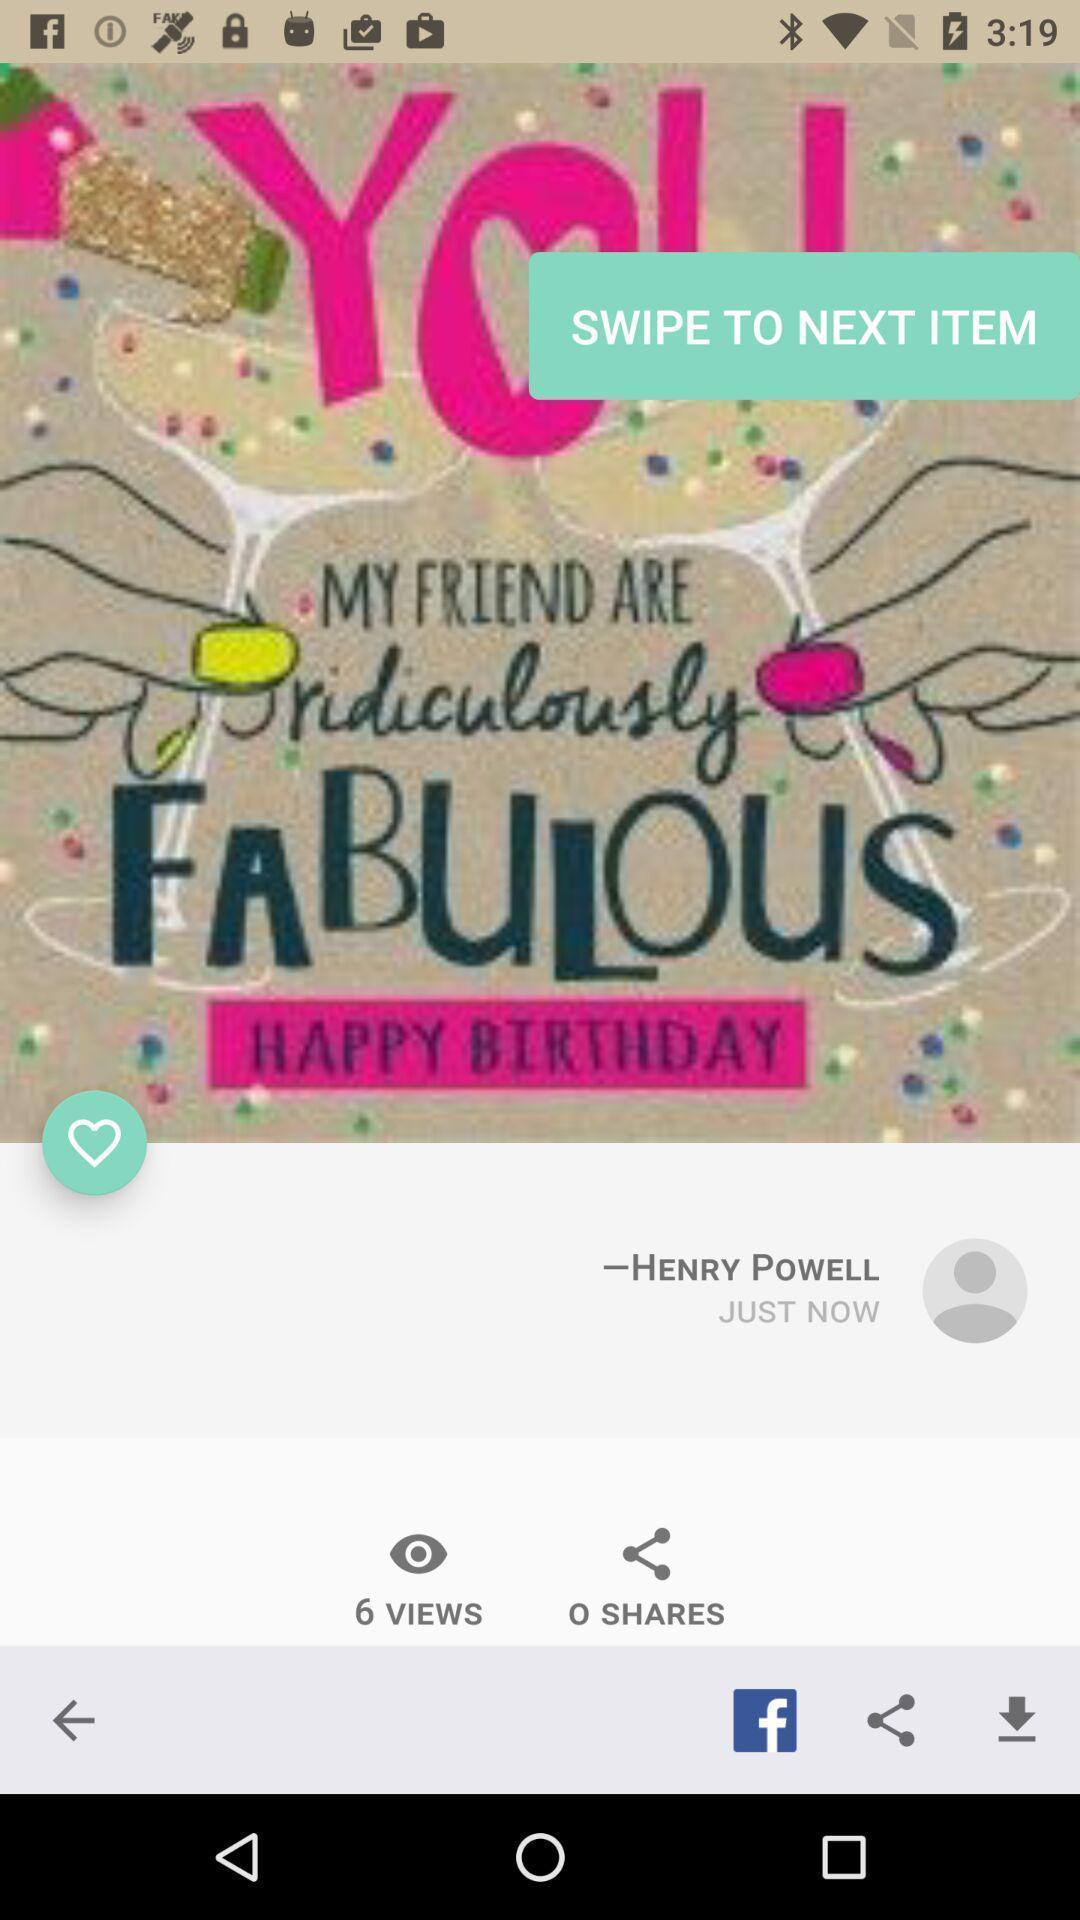Summarize the information in this screenshot. Screen shows a profile with multiple options. 